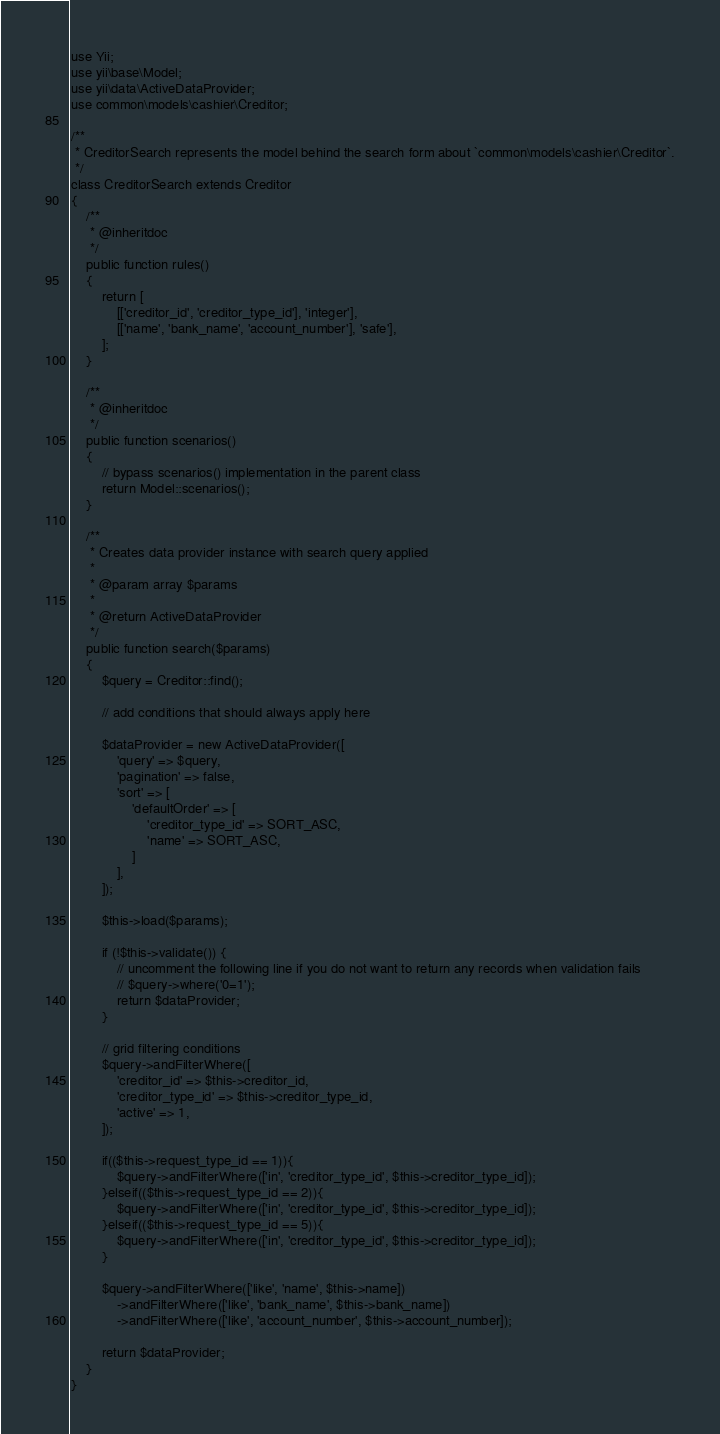<code> <loc_0><loc_0><loc_500><loc_500><_PHP_>use Yii;
use yii\base\Model;
use yii\data\ActiveDataProvider;
use common\models\cashier\Creditor;

/**
 * CreditorSearch represents the model behind the search form about `common\models\cashier\Creditor`.
 */
class CreditorSearch extends Creditor
{
    /**
     * @inheritdoc
     */
    public function rules()
    {
        return [
            [['creditor_id', 'creditor_type_id'], 'integer'],
            [['name', 'bank_name', 'account_number'], 'safe'],
        ];
    }

    /**
     * @inheritdoc
     */
    public function scenarios()
    {
        // bypass scenarios() implementation in the parent class
        return Model::scenarios();
    }

    /**
     * Creates data provider instance with search query applied
     *
     * @param array $params
     *
     * @return ActiveDataProvider
     */
    public function search($params)
    {
        $query = Creditor::find();

        // add conditions that should always apply here

        $dataProvider = new ActiveDataProvider([
            'query' => $query,
            'pagination' => false,
            'sort' => [
                'defaultOrder' => [
                    'creditor_type_id' => SORT_ASC,
                    'name' => SORT_ASC,
                ]
            ],
        ]);

        $this->load($params);

        if (!$this->validate()) {
            // uncomment the following line if you do not want to return any records when validation fails
            // $query->where('0=1');
            return $dataProvider;
        }

        // grid filtering conditions
        $query->andFilterWhere([
            'creditor_id' => $this->creditor_id,
            'creditor_type_id' => $this->creditor_type_id,
            'active' => 1,
        ]);
        
        if(($this->request_type_id == 1)){
            $query->andFilterWhere(['in', 'creditor_type_id', $this->creditor_type_id]);
        }elseif(($this->request_type_id == 2)){
            $query->andFilterWhere(['in', 'creditor_type_id', $this->creditor_type_id]);
        }elseif(($this->request_type_id == 5)){
            $query->andFilterWhere(['in', 'creditor_type_id', $this->creditor_type_id]);
        }

        $query->andFilterWhere(['like', 'name', $this->name])
            ->andFilterWhere(['like', 'bank_name', $this->bank_name])
            ->andFilterWhere(['like', 'account_number', $this->account_number]);

        return $dataProvider;
    }
}
</code> 